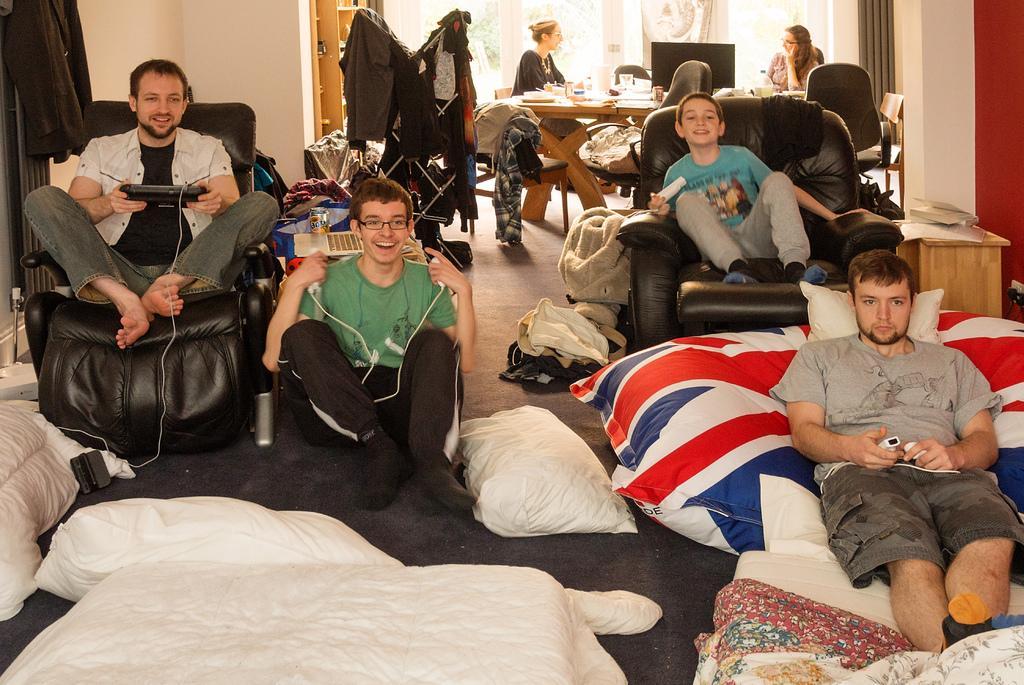Could you give a brief overview of what you see in this image? In the picture we can see inside the house with four people are sitting on sofa chairs and one one man is sitting on the bed which is white in color with pillow and near them we can see a floor with blanket and in the background we can see two woman are sitting on the chairs near the dining table and on it we can see some items and behind them we can see a door with glass to it and beside it we can see a rack. 